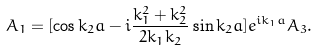Convert formula to latex. <formula><loc_0><loc_0><loc_500><loc_500>A _ { 1 } = [ \cos k _ { 2 } a - i \frac { k _ { 1 } ^ { 2 } + k _ { 2 } ^ { 2 } } { 2 k _ { 1 } k _ { 2 } } \sin k _ { 2 } a ] e ^ { i k _ { 1 } a } A _ { 3 } .</formula> 